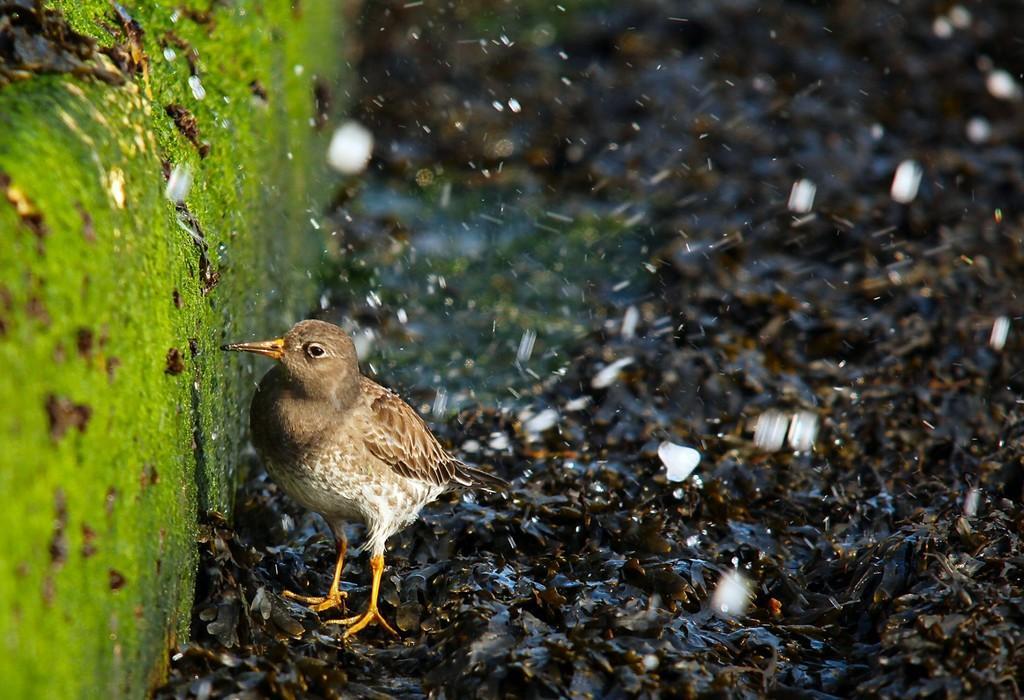How would you summarize this image in a sentence or two? We can see bird on surface and we can see algae. 